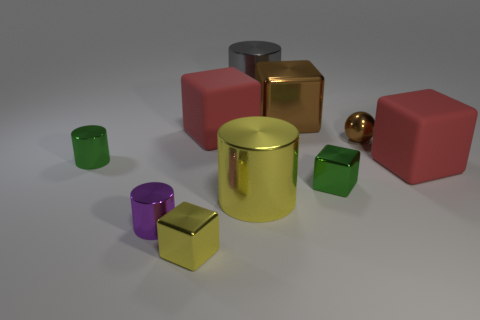Subtract all big brown blocks. How many blocks are left? 4 Subtract 1 spheres. How many spheres are left? 0 Subtract all green cubes. How many cubes are left? 4 Subtract all red cylinders. Subtract all yellow balls. How many cylinders are left? 4 Subtract all purple balls. How many blue blocks are left? 0 Subtract all yellow rubber spheres. Subtract all small green blocks. How many objects are left? 9 Add 7 red blocks. How many red blocks are left? 9 Add 10 big purple spheres. How many big purple spheres exist? 10 Subtract 0 brown cylinders. How many objects are left? 10 Subtract all balls. How many objects are left? 9 